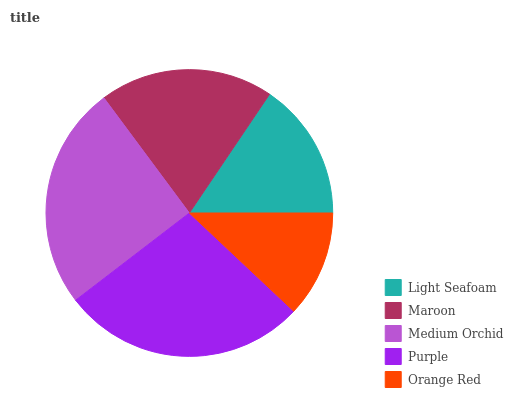Is Orange Red the minimum?
Answer yes or no. Yes. Is Purple the maximum?
Answer yes or no. Yes. Is Maroon the minimum?
Answer yes or no. No. Is Maroon the maximum?
Answer yes or no. No. Is Maroon greater than Light Seafoam?
Answer yes or no. Yes. Is Light Seafoam less than Maroon?
Answer yes or no. Yes. Is Light Seafoam greater than Maroon?
Answer yes or no. No. Is Maroon less than Light Seafoam?
Answer yes or no. No. Is Maroon the high median?
Answer yes or no. Yes. Is Maroon the low median?
Answer yes or no. Yes. Is Light Seafoam the high median?
Answer yes or no. No. Is Purple the low median?
Answer yes or no. No. 